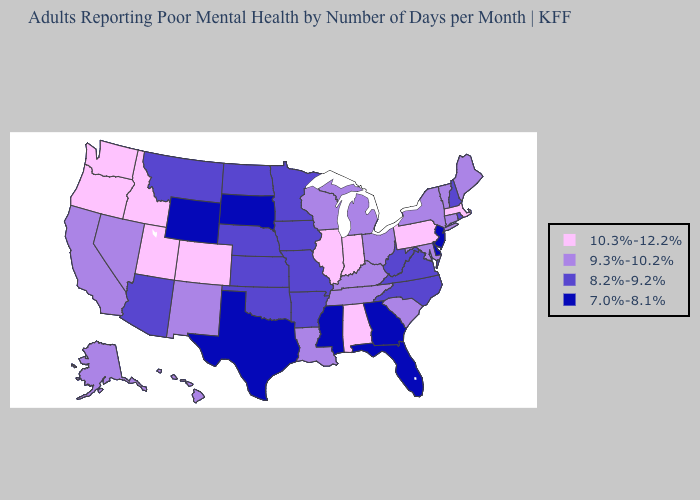What is the value of Mississippi?
Answer briefly. 7.0%-8.1%. Among the states that border Colorado , does Utah have the highest value?
Answer briefly. Yes. Name the states that have a value in the range 10.3%-12.2%?
Short answer required. Alabama, Colorado, Idaho, Illinois, Indiana, Massachusetts, Oregon, Pennsylvania, Utah, Washington. Does Washington have the same value as New York?
Quick response, please. No. Does Alabama have the lowest value in the USA?
Be succinct. No. What is the value of Pennsylvania?
Write a very short answer. 10.3%-12.2%. What is the value of Idaho?
Short answer required. 10.3%-12.2%. Which states have the highest value in the USA?
Concise answer only. Alabama, Colorado, Idaho, Illinois, Indiana, Massachusetts, Oregon, Pennsylvania, Utah, Washington. What is the value of Missouri?
Write a very short answer. 8.2%-9.2%. What is the value of Delaware?
Quick response, please. 7.0%-8.1%. What is the value of California?
Be succinct. 9.3%-10.2%. Does South Carolina have the same value as Alabama?
Give a very brief answer. No. Is the legend a continuous bar?
Short answer required. No. Name the states that have a value in the range 9.3%-10.2%?
Keep it brief. Alaska, California, Connecticut, Hawaii, Kentucky, Louisiana, Maine, Maryland, Michigan, Nevada, New Mexico, New York, Ohio, South Carolina, Tennessee, Vermont, Wisconsin. Which states have the lowest value in the West?
Quick response, please. Wyoming. 